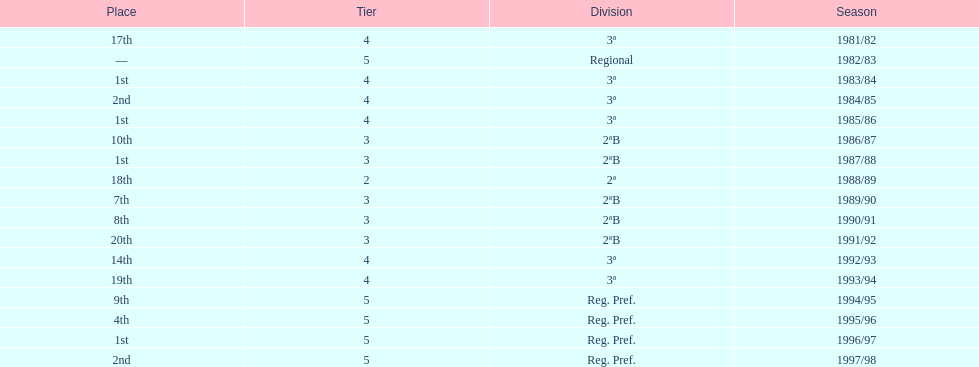What year has no place indicated? 1982/83. Write the full table. {'header': ['Place', 'Tier', 'Division', 'Season'], 'rows': [['17th', '4', '3ª', '1981/82'], ['—', '5', 'Regional', '1982/83'], ['1st', '4', '3ª', '1983/84'], ['2nd', '4', '3ª', '1984/85'], ['1st', '4', '3ª', '1985/86'], ['10th', '3', '2ªB', '1986/87'], ['1st', '3', '2ªB', '1987/88'], ['18th', '2', '2ª', '1988/89'], ['7th', '3', '2ªB', '1989/90'], ['8th', '3', '2ªB', '1990/91'], ['20th', '3', '2ªB', '1991/92'], ['14th', '4', '3ª', '1992/93'], ['19th', '4', '3ª', '1993/94'], ['9th', '5', 'Reg. Pref.', '1994/95'], ['4th', '5', 'Reg. Pref.', '1995/96'], ['1st', '5', 'Reg. Pref.', '1996/97'], ['2nd', '5', 'Reg. Pref.', '1997/98']]} 